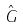<formula> <loc_0><loc_0><loc_500><loc_500>\hat { G }</formula> 